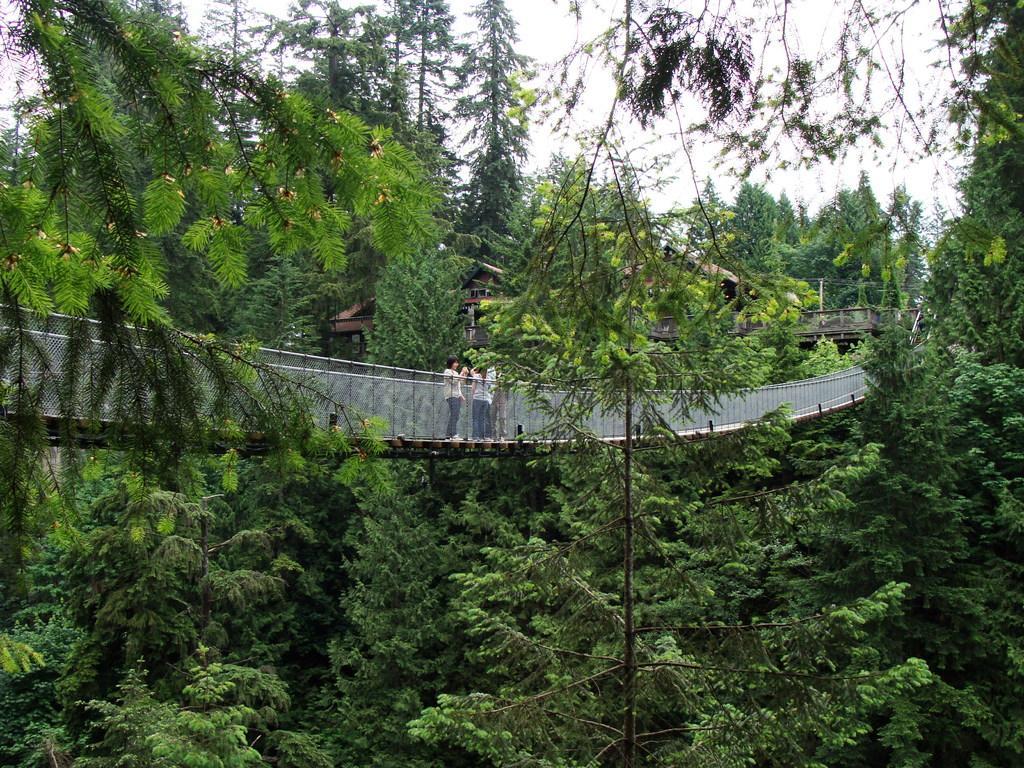Describe this image in one or two sentences. This image is taken outdoors. At the top of the image there is the sky. In the middle of the image there is a bridge and a few people are standing on the bridge. There are many trees with green leaves, stems and branches. 